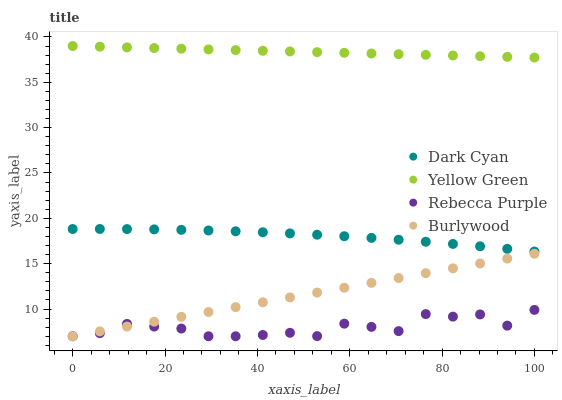Does Rebecca Purple have the minimum area under the curve?
Answer yes or no. Yes. Does Yellow Green have the maximum area under the curve?
Answer yes or no. Yes. Does Burlywood have the minimum area under the curve?
Answer yes or no. No. Does Burlywood have the maximum area under the curve?
Answer yes or no. No. Is Burlywood the smoothest?
Answer yes or no. Yes. Is Rebecca Purple the roughest?
Answer yes or no. Yes. Is Yellow Green the smoothest?
Answer yes or no. No. Is Yellow Green the roughest?
Answer yes or no. No. Does Burlywood have the lowest value?
Answer yes or no. Yes. Does Yellow Green have the lowest value?
Answer yes or no. No. Does Yellow Green have the highest value?
Answer yes or no. Yes. Does Burlywood have the highest value?
Answer yes or no. No. Is Rebecca Purple less than Dark Cyan?
Answer yes or no. Yes. Is Yellow Green greater than Burlywood?
Answer yes or no. Yes. Does Burlywood intersect Rebecca Purple?
Answer yes or no. Yes. Is Burlywood less than Rebecca Purple?
Answer yes or no. No. Is Burlywood greater than Rebecca Purple?
Answer yes or no. No. Does Rebecca Purple intersect Dark Cyan?
Answer yes or no. No. 